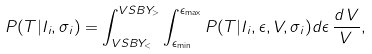<formula> <loc_0><loc_0><loc_500><loc_500>P ( T | I _ { i } , \sigma _ { i } ) = \int _ { V S B Y _ { < } } ^ { V S B Y _ { > } } \int _ { \epsilon _ { \min } } ^ { \epsilon _ { \max } } P ( T | I _ { i } , \epsilon , V , \sigma _ { i } ) d \epsilon \, \frac { d \, V } { V } ,</formula> 